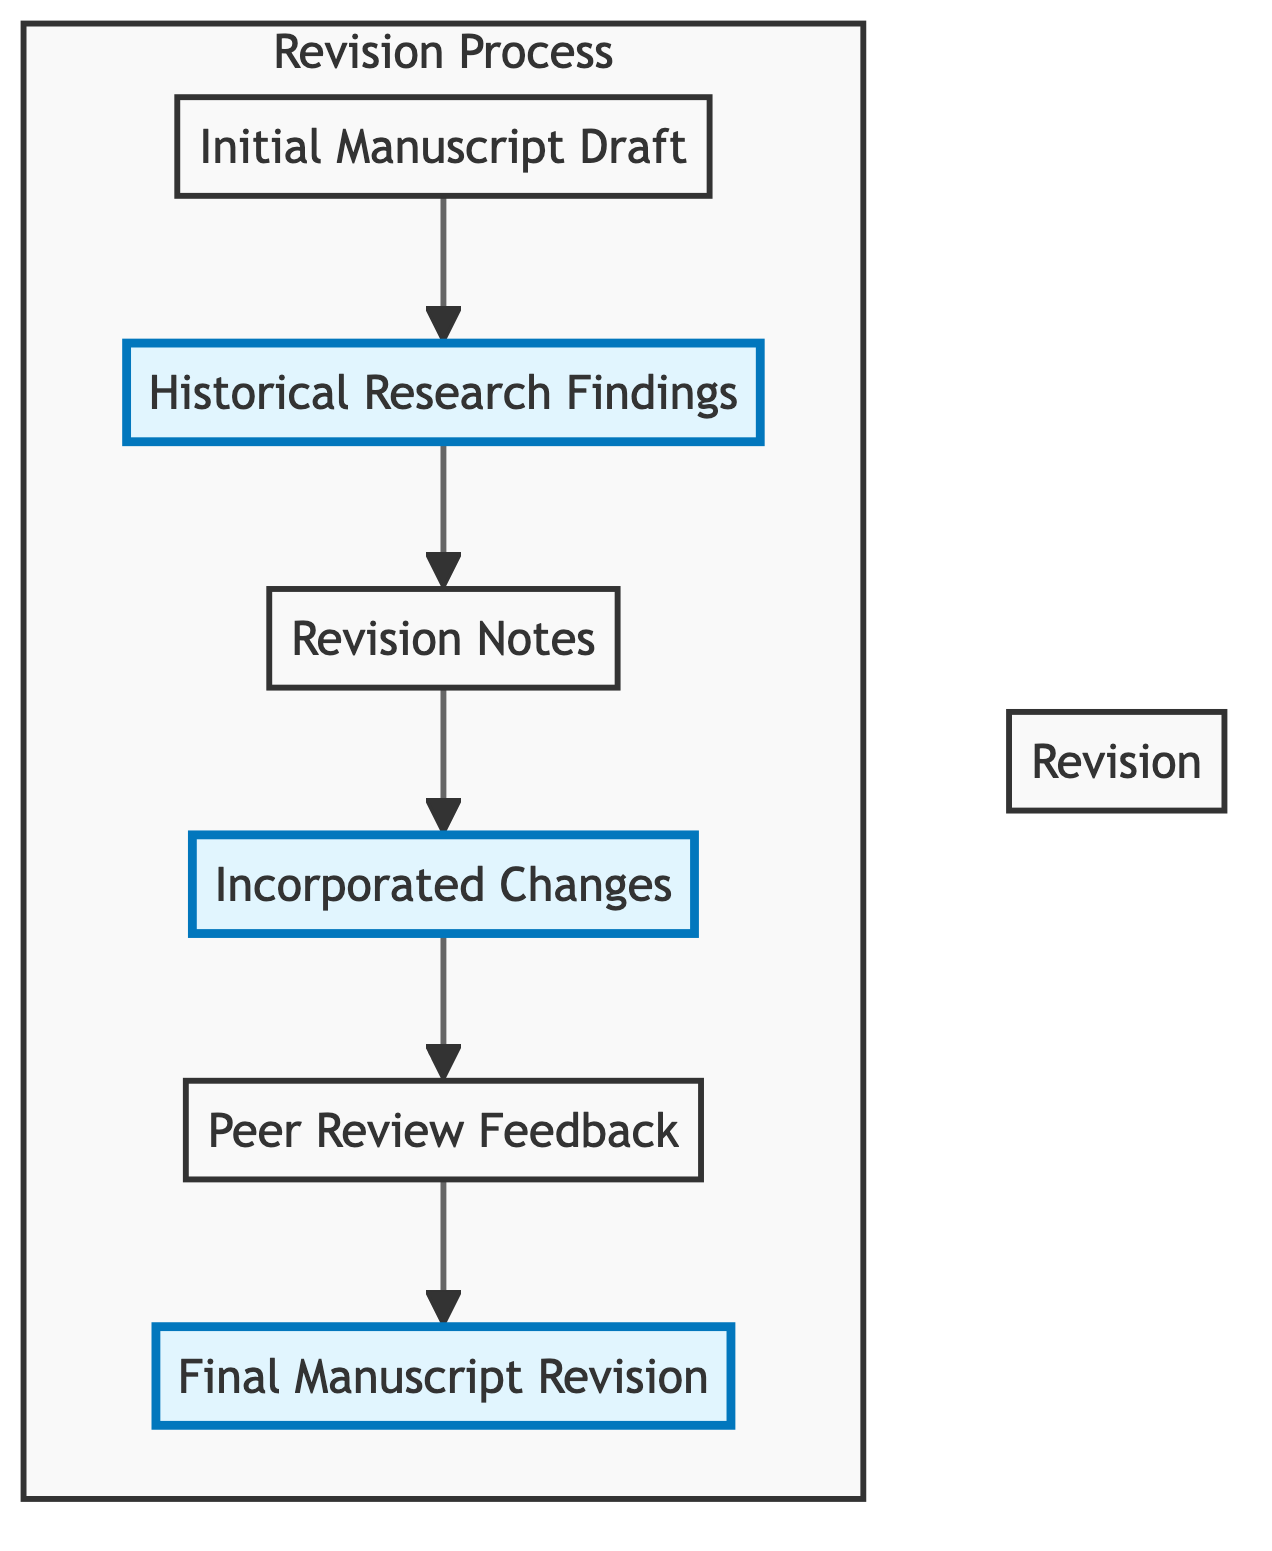What is the first node in the flow chart? The first node is "Initial Manuscript Draft," as it is the starting point from which the process begins.
Answer: Initial Manuscript Draft How many nodes are there in total? The flow chart contains six nodes: Initial Manuscript Draft, Historical Research Findings, Revision Notes, Incorporated Changes, Peer Review Feedback, and Final Manuscript Revision.
Answer: 6 What node comes after "Revision Notes"? "Incorporated Changes" directly follows "Revision Notes," indicating the next step in the process after taking notes on revisions.
Answer: Incorporated Changes What type of feedback is provided in the flow chart? The flow chart specifies "Peer Review Feedback," which refers to insights from peer authors or historians regarding historical accuracy.
Answer: Peer Review Feedback Which node represents the final outcome of the revision process? The final outcome of the process is represented by the node "Final Manuscript Revision," showcasing the completed version of the novel.
Answer: Final Manuscript Revision How many connections are made from the "Historical Research Findings" node? "Historical Research Findings" has one outgoing connection leading to "Revision Notes," signifying that findings lead to the next step of making revisions.
Answer: 1 What is the relationship between "Incorporated Changes" and "Peer Review Feedback"? "Incorporated Changes" leads to "Peer Review Feedback," suggesting that changes made to the manuscript are then reviewed by peers for further feedback.
Answer: Leads to Which nodes are highlighted in the flow chart? The highlighted nodes are "Historical Research Findings," "Incorporated Changes," and "Final Manuscript Revision," indicating key steps in the revision process that are significant.
Answer: Historical Research Findings, Incorporated Changes, Final Manuscript Revision What is the purpose of the "Revision Notes" node? "Revision Notes" serves to document comments and observations that arise from reviewing historical research findings, acting as a bridge to make specific changes.
Answer: Documenting comments and observations 